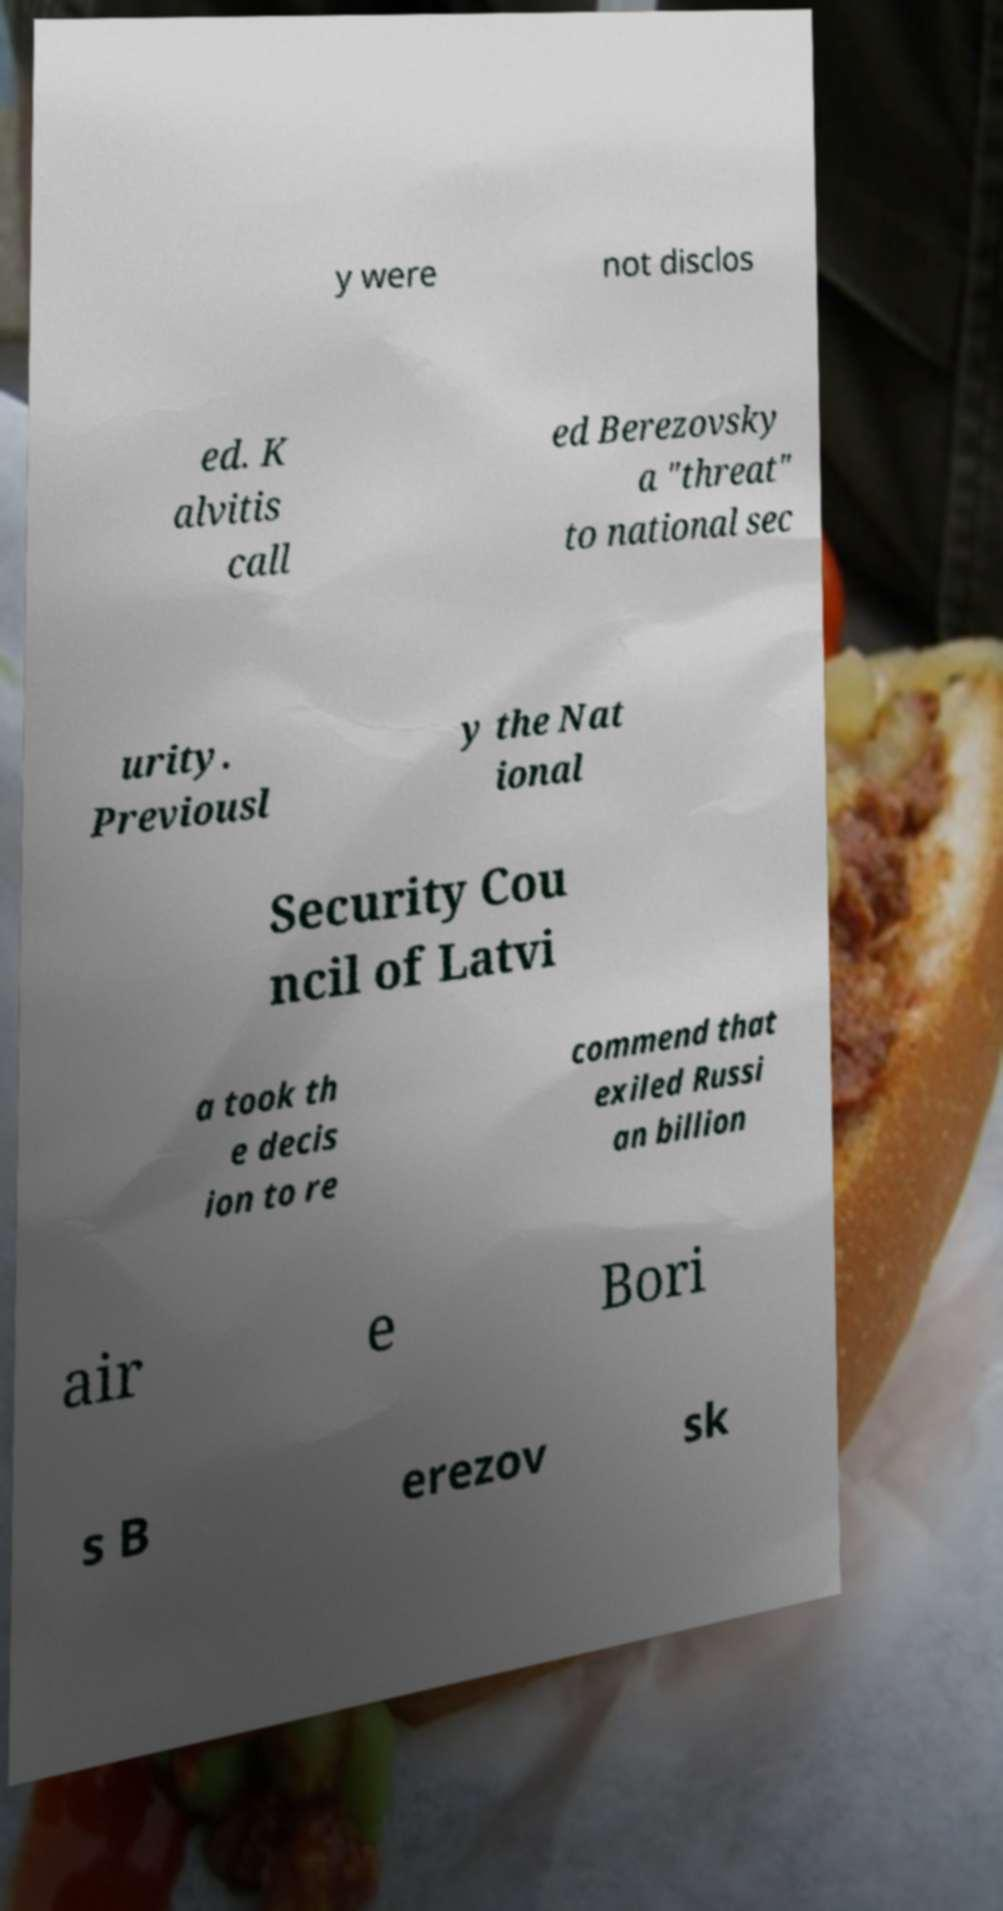Please identify and transcribe the text found in this image. y were not disclos ed. K alvitis call ed Berezovsky a "threat" to national sec urity. Previousl y the Nat ional Security Cou ncil of Latvi a took th e decis ion to re commend that exiled Russi an billion air e Bori s B erezov sk 